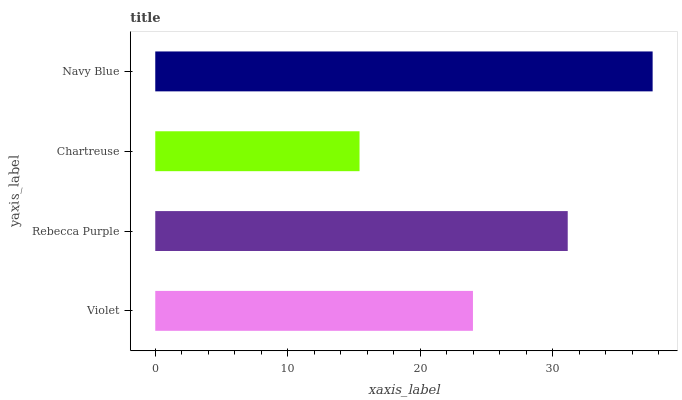Is Chartreuse the minimum?
Answer yes or no. Yes. Is Navy Blue the maximum?
Answer yes or no. Yes. Is Rebecca Purple the minimum?
Answer yes or no. No. Is Rebecca Purple the maximum?
Answer yes or no. No. Is Rebecca Purple greater than Violet?
Answer yes or no. Yes. Is Violet less than Rebecca Purple?
Answer yes or no. Yes. Is Violet greater than Rebecca Purple?
Answer yes or no. No. Is Rebecca Purple less than Violet?
Answer yes or no. No. Is Rebecca Purple the high median?
Answer yes or no. Yes. Is Violet the low median?
Answer yes or no. Yes. Is Navy Blue the high median?
Answer yes or no. No. Is Rebecca Purple the low median?
Answer yes or no. No. 